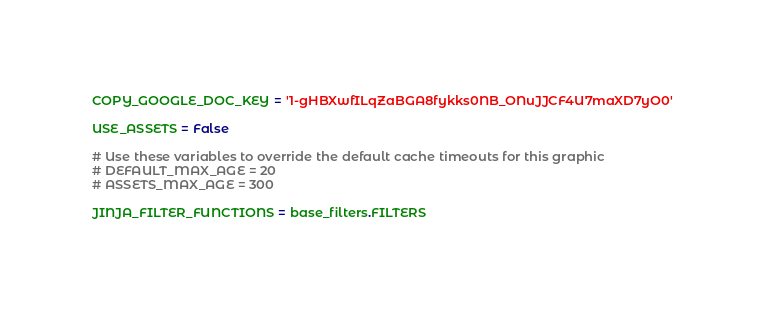<code> <loc_0><loc_0><loc_500><loc_500><_Python_>COPY_GOOGLE_DOC_KEY = '1-gHBXwfILqZaBGA8fykks0NB_ONuJJCF4U7maXD7yO0'

USE_ASSETS = False

# Use these variables to override the default cache timeouts for this graphic
# DEFAULT_MAX_AGE = 20
# ASSETS_MAX_AGE = 300

JINJA_FILTER_FUNCTIONS = base_filters.FILTERS
</code> 